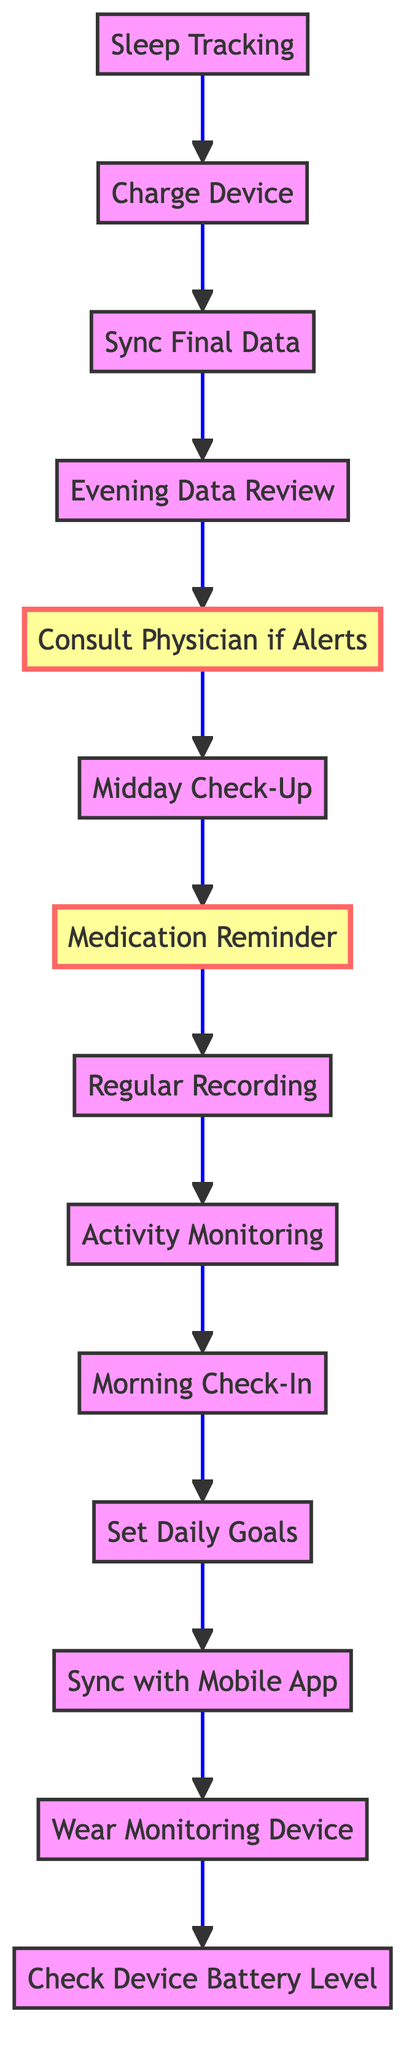What is the first step in the daily health monitoring routine? The first step is "Check Device Battery Level," which is the starting point at the bottom of the flow chart.
Answer: Check Device Battery Level How many nodes are in the diagram? To find the number of nodes, we count each distinct element in the diagram. There are 13 elements total.
Answer: 13 What is the last step before charging the device? The last step before "Charge Device" is "Sleep Tracking," which is positioned just above "Charge Device" in the flow.
Answer: Sleep Tracking Which step follows "Medication Reminder"? The step that follows "Medication Reminder" is "Regular Recording," as indicated by the upward flow towards the next instruction in the chart.
Answer: Regular Recording Is "Consult Physician if Alerts" considered an important step? Yes, "Consult Physician if Alerts" is marked as an important step in the flow chart as indicated by its distinctive styling.
Answer: Yes What are the two steps that require immediate action based on alerts? The two steps that require immediate action are "Consult Physician if Alerts" and "Medication Reminder." Both are crucial for addressing potential issues with heart health.
Answer: Consult Physician if Alerts, Medication Reminder What is the relationship between "Evening Data Review" and "Sync Final Data"? The relationship is that "Sync Final Data" directly precedes "Evening Data Review," indicating that final data should be synced before reviewing the daily summary.
Answer: Sync Final Data precedes Evening Data Review If the device alerts a user, what step should they take next? If the device alerts a user, they should take the step "Consult Physician if Alerts," as indicated by the flour flow direction leading from potential alerts to this action.
Answer: Consult Physician if Alerts What step do you perform after "Midday Check-Up"? After "Midday Check-Up," the next step is "Medication Reminder," which follows the continuous effort to monitor and address health throughout the day.
Answer: Medication Reminder 